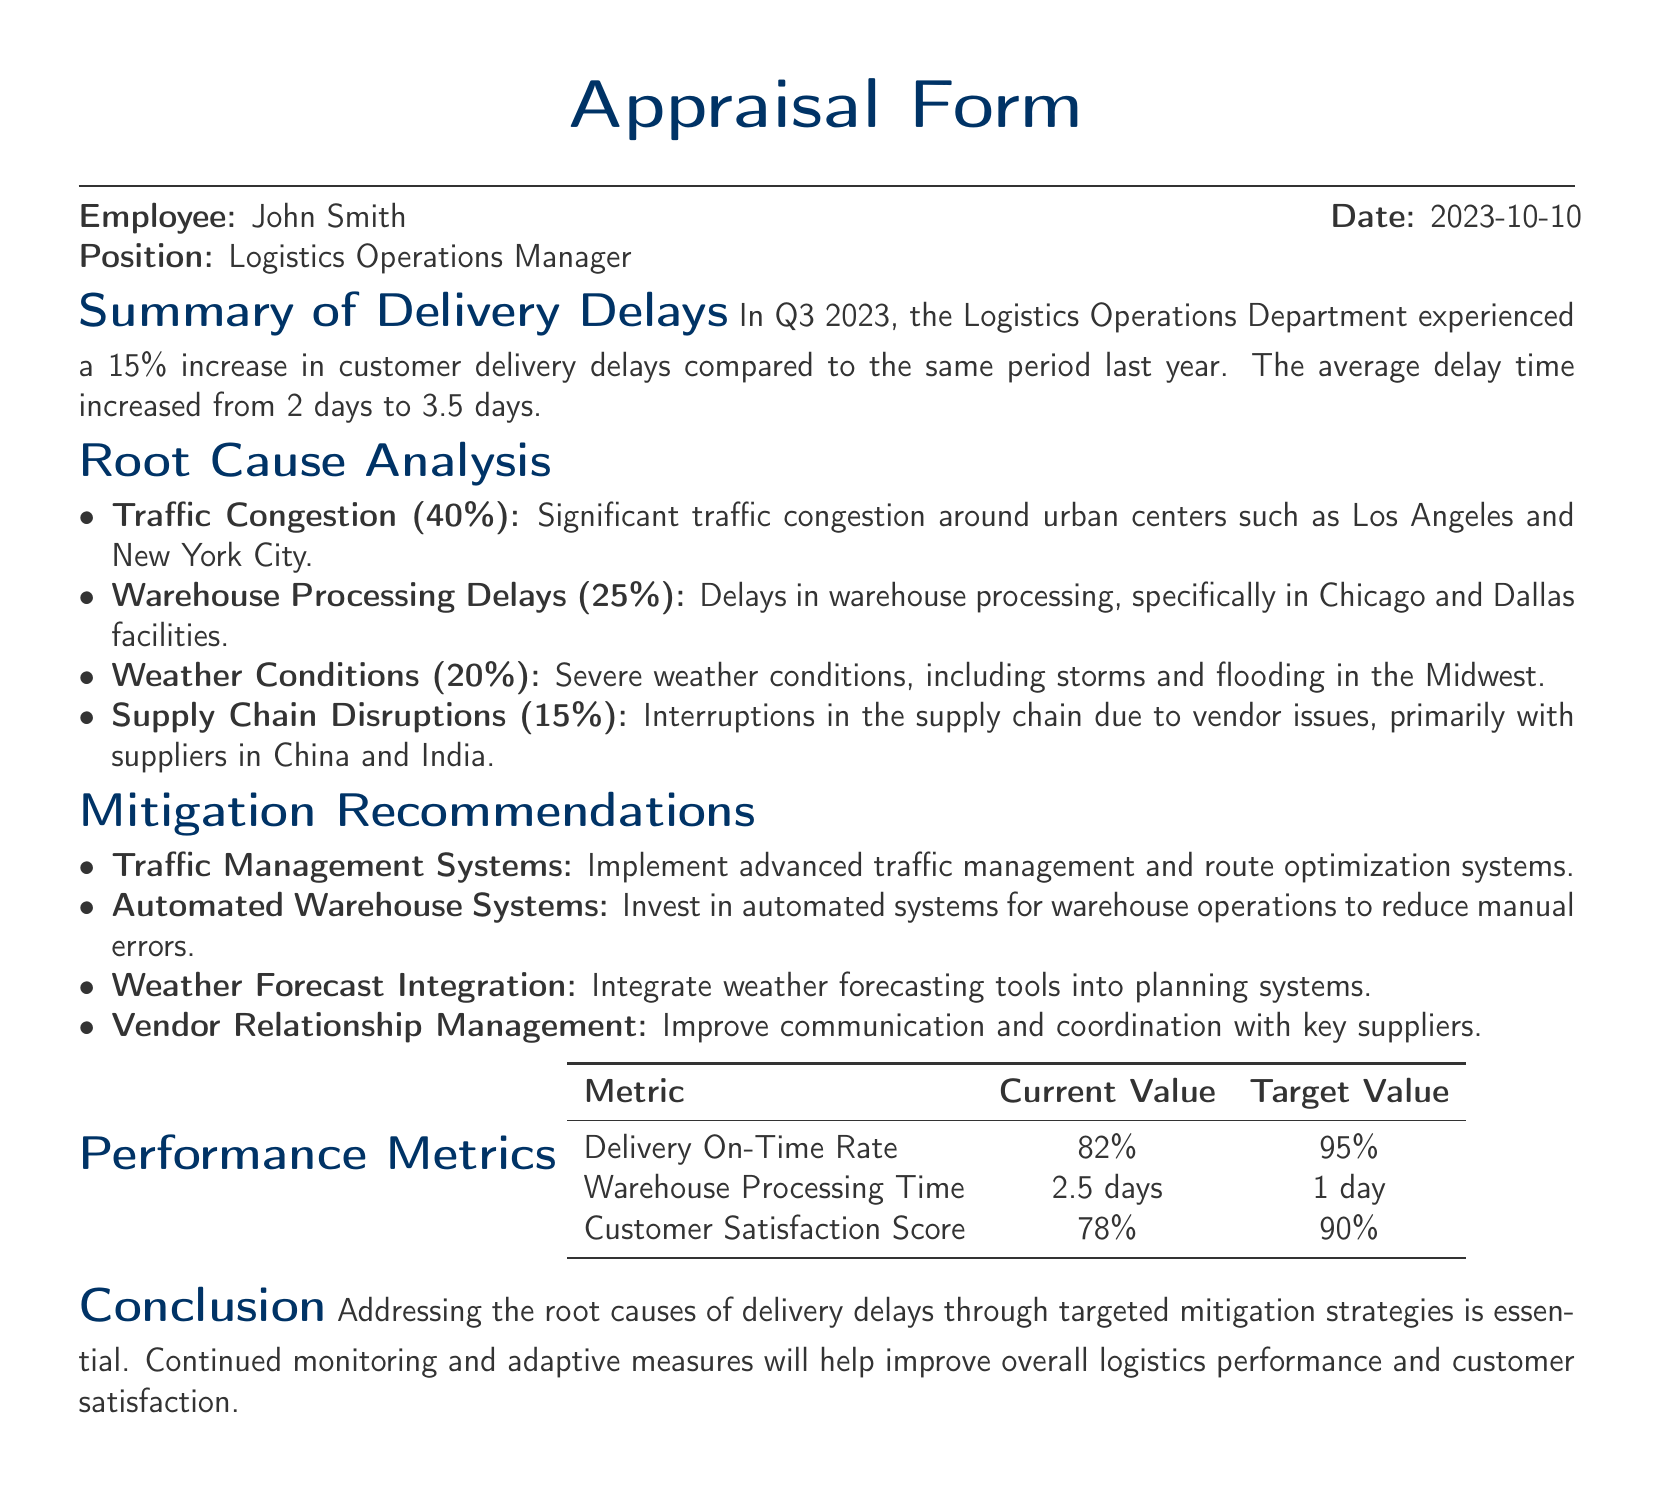what was the increase in customer delivery delays in Q3 2023? The document states there was a 15% increase in customer delivery delays compared to the same period last year.
Answer: 15% what was the average delay time for deliveries in Q3 2023? The average delay time increased from 2 days to 3.5 days in Q3 2023.
Answer: 3.5 days what percentage of delivery delays was caused by traffic congestion? The document indicates that 40% of delivery delays were due to traffic congestion.
Answer: 40% what is the target value for the Delivery On-Time Rate? The performance metrics section lists the target value for the Delivery On-Time Rate as 95%.
Answer: 95% which city had warehouse processing delays? The document specifically mentions delays in warehouse processing in Chicago and Dallas.
Answer: Chicago and Dallas what system is recommended to handle traffic congestion? The mitigation recommendations suggest implementing advanced traffic management systems.
Answer: advanced traffic management systems how much is the current Customer Satisfaction Score? The current Customer Satisfaction Score listed in the performance metrics is 78%.
Answer: 78% what is the percentage of delays due to weather conditions? The document attributes 20% of delivery delays to severe weather conditions.
Answer: 20% what is one of the recommendations regarding vendor issues? The document recommends improving communication and coordination with key suppliers.
Answer: improve communication and coordination with key suppliers 